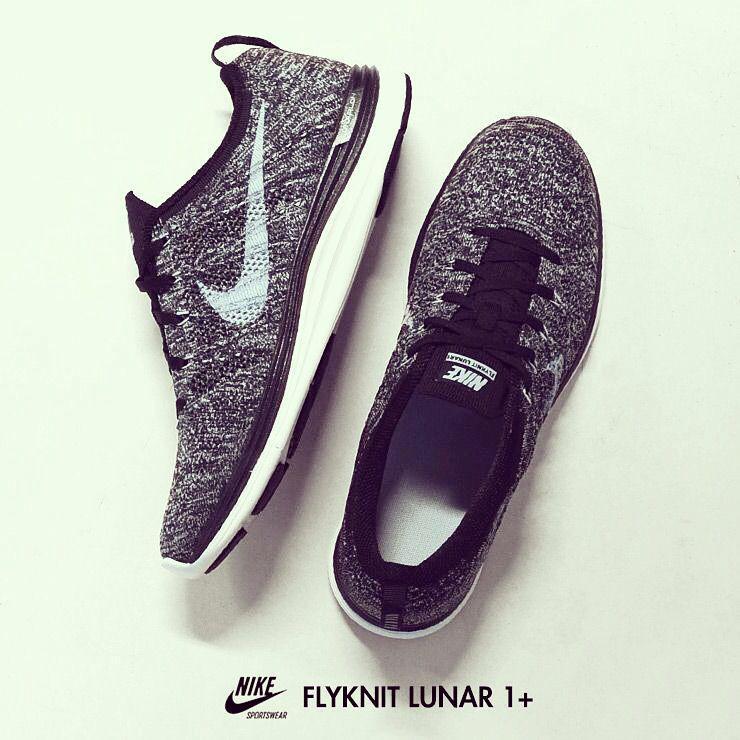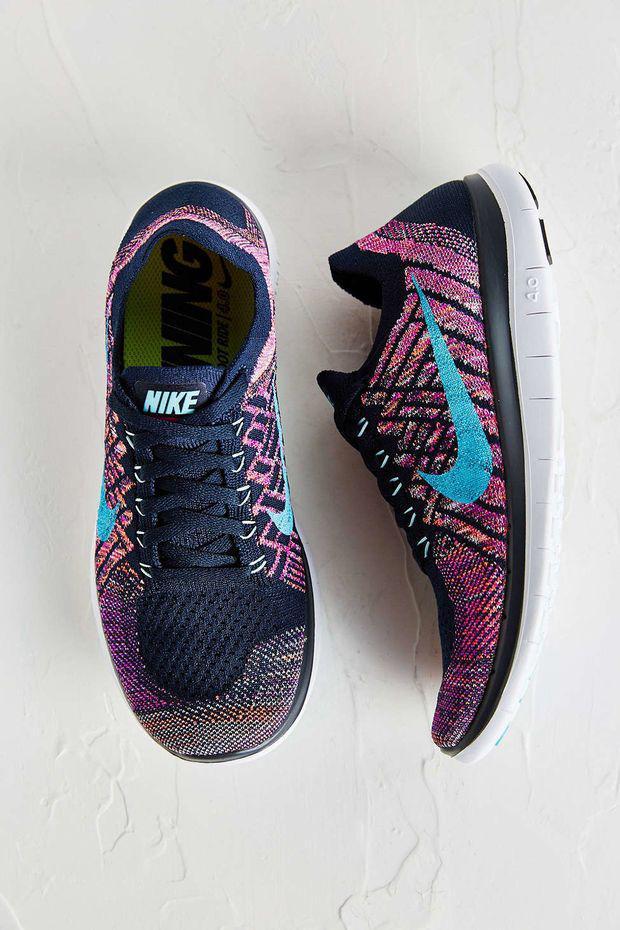The first image is the image on the left, the second image is the image on the right. Analyze the images presented: Is the assertion "In the right image, the shoe on the right has a swoop design visible." valid? Answer yes or no. Yes. 